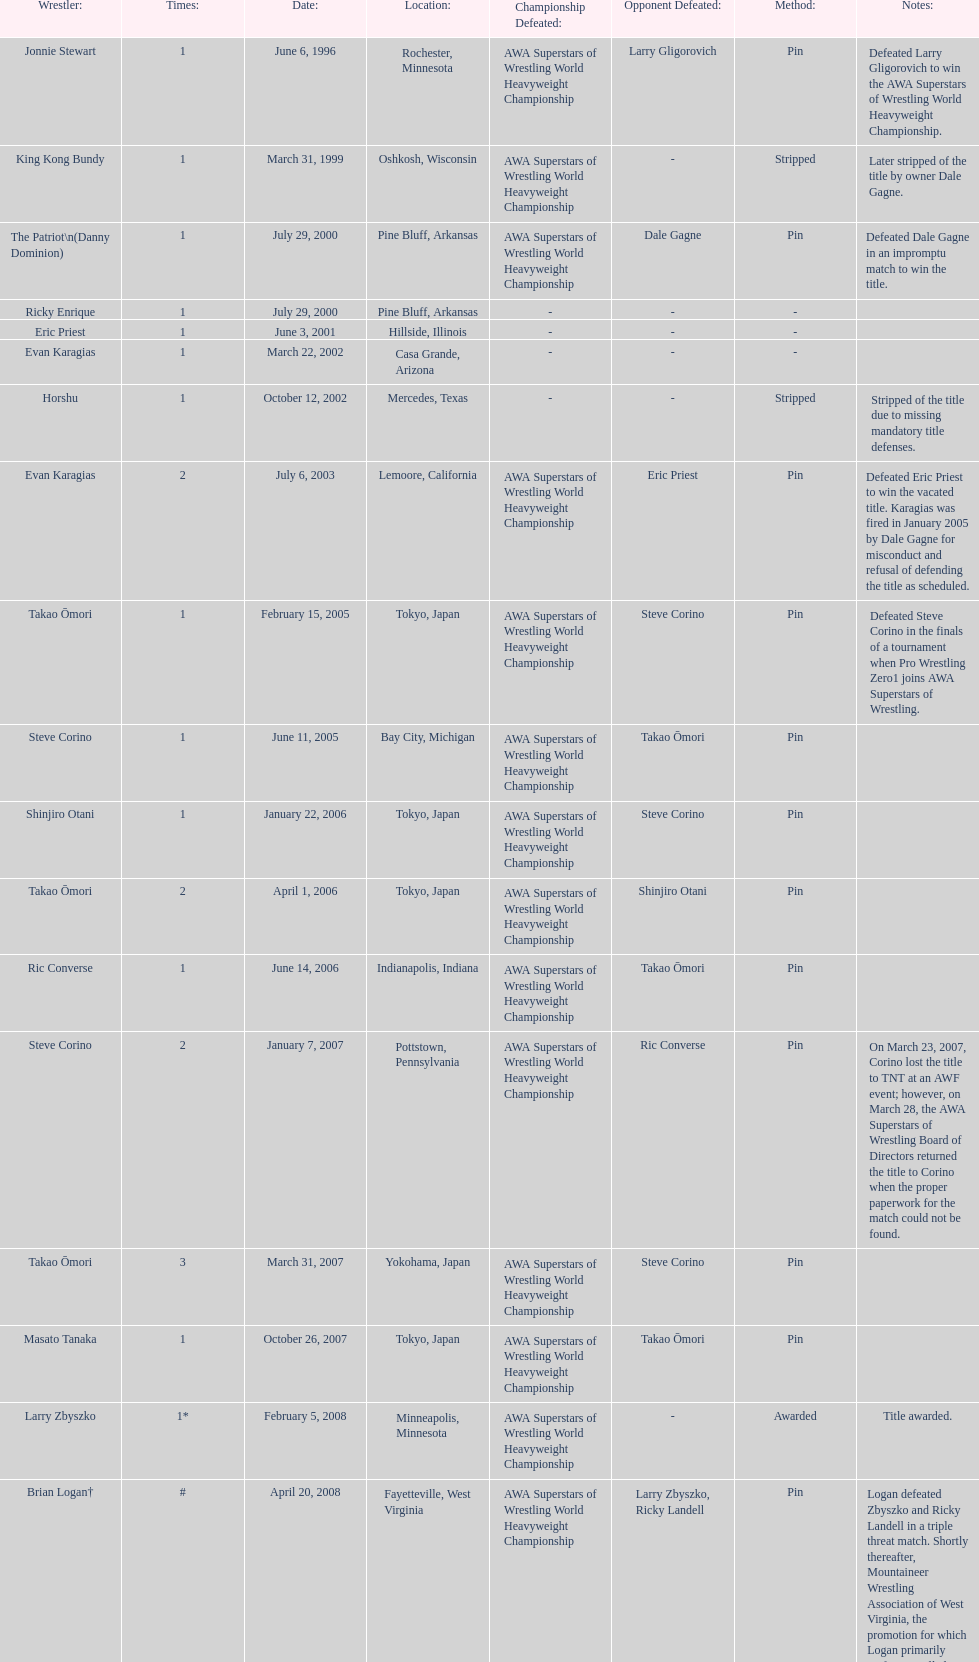The patriot (danny dominion) won the title from what previous holder through an impromptu match? Dale Gagne. 